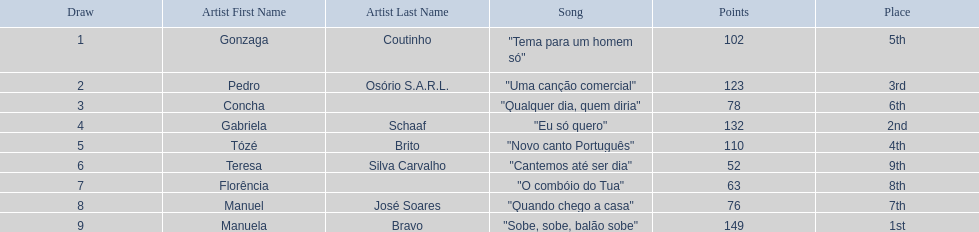Is there a song called eu so quero in the table? "Eu só quero". Who sang that song? Gabriela Schaaf. 